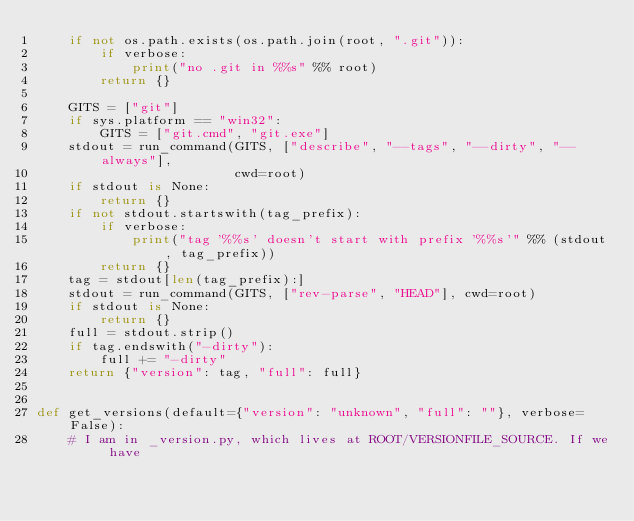Convert code to text. <code><loc_0><loc_0><loc_500><loc_500><_Python_>    if not os.path.exists(os.path.join(root, ".git")):
        if verbose:
            print("no .git in %%s" %% root)
        return {}

    GITS = ["git"]
    if sys.platform == "win32":
        GITS = ["git.cmd", "git.exe"]
    stdout = run_command(GITS, ["describe", "--tags", "--dirty", "--always"],
                         cwd=root)
    if stdout is None:
        return {}
    if not stdout.startswith(tag_prefix):
        if verbose:
            print("tag '%%s' doesn't start with prefix '%%s'" %% (stdout, tag_prefix))
        return {}
    tag = stdout[len(tag_prefix):]
    stdout = run_command(GITS, ["rev-parse", "HEAD"], cwd=root)
    if stdout is None:
        return {}
    full = stdout.strip()
    if tag.endswith("-dirty"):
        full += "-dirty"
    return {"version": tag, "full": full}


def get_versions(default={"version": "unknown", "full": ""}, verbose=False):
    # I am in _version.py, which lives at ROOT/VERSIONFILE_SOURCE. If we have</code> 